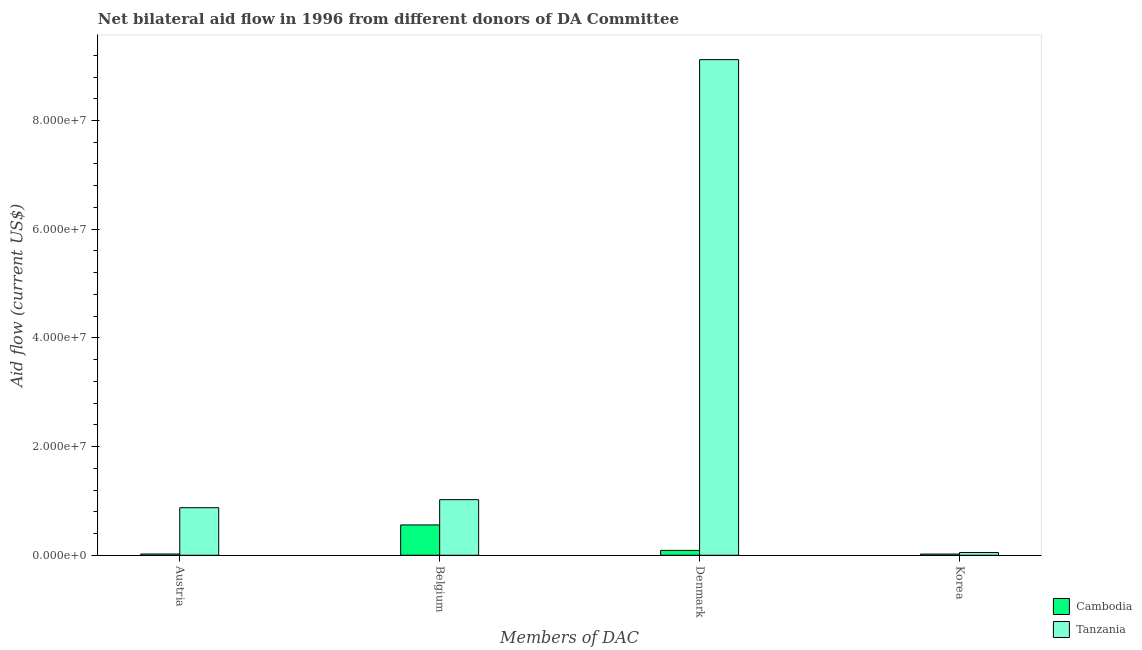How many different coloured bars are there?
Your answer should be compact. 2. How many groups of bars are there?
Offer a very short reply. 4. How many bars are there on the 1st tick from the left?
Keep it short and to the point. 2. What is the label of the 4th group of bars from the left?
Your response must be concise. Korea. What is the amount of aid given by belgium in Cambodia?
Provide a short and direct response. 5.58e+06. Across all countries, what is the maximum amount of aid given by denmark?
Give a very brief answer. 9.12e+07. Across all countries, what is the minimum amount of aid given by belgium?
Offer a terse response. 5.58e+06. In which country was the amount of aid given by austria maximum?
Keep it short and to the point. Tanzania. In which country was the amount of aid given by belgium minimum?
Provide a succinct answer. Cambodia. What is the total amount of aid given by austria in the graph?
Make the answer very short. 8.98e+06. What is the difference between the amount of aid given by korea in Cambodia and that in Tanzania?
Offer a very short reply. -2.80e+05. What is the difference between the amount of aid given by korea in Cambodia and the amount of aid given by belgium in Tanzania?
Provide a short and direct response. -1.00e+07. What is the average amount of aid given by belgium per country?
Offer a terse response. 7.90e+06. What is the difference between the amount of aid given by korea and amount of aid given by denmark in Cambodia?
Your response must be concise. -6.80e+05. What is the ratio of the amount of aid given by korea in Tanzania to that in Cambodia?
Provide a succinct answer. 2.27. Is the amount of aid given by belgium in Cambodia less than that in Tanzania?
Ensure brevity in your answer.  Yes. What is the difference between the highest and the second highest amount of aid given by denmark?
Provide a succinct answer. 9.03e+07. What is the difference between the highest and the lowest amount of aid given by austria?
Your answer should be very brief. 8.52e+06. In how many countries, is the amount of aid given by belgium greater than the average amount of aid given by belgium taken over all countries?
Make the answer very short. 1. What does the 2nd bar from the left in Belgium represents?
Offer a terse response. Tanzania. What does the 2nd bar from the right in Belgium represents?
Offer a terse response. Cambodia. Is it the case that in every country, the sum of the amount of aid given by austria and amount of aid given by belgium is greater than the amount of aid given by denmark?
Make the answer very short. No. Are all the bars in the graph horizontal?
Keep it short and to the point. No. How many countries are there in the graph?
Keep it short and to the point. 2. What is the difference between two consecutive major ticks on the Y-axis?
Provide a short and direct response. 2.00e+07. Are the values on the major ticks of Y-axis written in scientific E-notation?
Your response must be concise. Yes. Does the graph contain any zero values?
Keep it short and to the point. No. Does the graph contain grids?
Ensure brevity in your answer.  No. Where does the legend appear in the graph?
Your answer should be very brief. Bottom right. How are the legend labels stacked?
Your response must be concise. Vertical. What is the title of the graph?
Provide a succinct answer. Net bilateral aid flow in 1996 from different donors of DA Committee. Does "Suriname" appear as one of the legend labels in the graph?
Provide a succinct answer. No. What is the label or title of the X-axis?
Your response must be concise. Members of DAC. What is the label or title of the Y-axis?
Offer a very short reply. Aid flow (current US$). What is the Aid flow (current US$) of Cambodia in Austria?
Offer a terse response. 2.30e+05. What is the Aid flow (current US$) in Tanzania in Austria?
Keep it short and to the point. 8.75e+06. What is the Aid flow (current US$) in Cambodia in Belgium?
Your answer should be very brief. 5.58e+06. What is the Aid flow (current US$) in Tanzania in Belgium?
Offer a terse response. 1.02e+07. What is the Aid flow (current US$) in Tanzania in Denmark?
Your response must be concise. 9.12e+07. Across all Members of DAC, what is the maximum Aid flow (current US$) in Cambodia?
Offer a very short reply. 5.58e+06. Across all Members of DAC, what is the maximum Aid flow (current US$) in Tanzania?
Your answer should be compact. 9.12e+07. Across all Members of DAC, what is the minimum Aid flow (current US$) in Cambodia?
Keep it short and to the point. 2.20e+05. Across all Members of DAC, what is the minimum Aid flow (current US$) in Tanzania?
Give a very brief answer. 5.00e+05. What is the total Aid flow (current US$) of Cambodia in the graph?
Your answer should be compact. 6.93e+06. What is the total Aid flow (current US$) in Tanzania in the graph?
Your response must be concise. 1.11e+08. What is the difference between the Aid flow (current US$) of Cambodia in Austria and that in Belgium?
Ensure brevity in your answer.  -5.35e+06. What is the difference between the Aid flow (current US$) in Tanzania in Austria and that in Belgium?
Make the answer very short. -1.48e+06. What is the difference between the Aid flow (current US$) in Cambodia in Austria and that in Denmark?
Provide a succinct answer. -6.70e+05. What is the difference between the Aid flow (current US$) in Tanzania in Austria and that in Denmark?
Provide a short and direct response. -8.24e+07. What is the difference between the Aid flow (current US$) in Tanzania in Austria and that in Korea?
Your answer should be compact. 8.25e+06. What is the difference between the Aid flow (current US$) of Cambodia in Belgium and that in Denmark?
Offer a very short reply. 4.68e+06. What is the difference between the Aid flow (current US$) of Tanzania in Belgium and that in Denmark?
Your answer should be compact. -8.10e+07. What is the difference between the Aid flow (current US$) in Cambodia in Belgium and that in Korea?
Ensure brevity in your answer.  5.36e+06. What is the difference between the Aid flow (current US$) of Tanzania in Belgium and that in Korea?
Your answer should be very brief. 9.73e+06. What is the difference between the Aid flow (current US$) of Cambodia in Denmark and that in Korea?
Ensure brevity in your answer.  6.80e+05. What is the difference between the Aid flow (current US$) of Tanzania in Denmark and that in Korea?
Provide a short and direct response. 9.07e+07. What is the difference between the Aid flow (current US$) of Cambodia in Austria and the Aid flow (current US$) of Tanzania in Belgium?
Offer a very short reply. -1.00e+07. What is the difference between the Aid flow (current US$) of Cambodia in Austria and the Aid flow (current US$) of Tanzania in Denmark?
Offer a very short reply. -9.10e+07. What is the difference between the Aid flow (current US$) in Cambodia in Belgium and the Aid flow (current US$) in Tanzania in Denmark?
Your response must be concise. -8.56e+07. What is the difference between the Aid flow (current US$) in Cambodia in Belgium and the Aid flow (current US$) in Tanzania in Korea?
Give a very brief answer. 5.08e+06. What is the average Aid flow (current US$) in Cambodia per Members of DAC?
Provide a short and direct response. 1.73e+06. What is the average Aid flow (current US$) of Tanzania per Members of DAC?
Offer a terse response. 2.77e+07. What is the difference between the Aid flow (current US$) of Cambodia and Aid flow (current US$) of Tanzania in Austria?
Give a very brief answer. -8.52e+06. What is the difference between the Aid flow (current US$) of Cambodia and Aid flow (current US$) of Tanzania in Belgium?
Provide a succinct answer. -4.65e+06. What is the difference between the Aid flow (current US$) in Cambodia and Aid flow (current US$) in Tanzania in Denmark?
Make the answer very short. -9.03e+07. What is the difference between the Aid flow (current US$) of Cambodia and Aid flow (current US$) of Tanzania in Korea?
Give a very brief answer. -2.80e+05. What is the ratio of the Aid flow (current US$) of Cambodia in Austria to that in Belgium?
Your response must be concise. 0.04. What is the ratio of the Aid flow (current US$) in Tanzania in Austria to that in Belgium?
Your answer should be very brief. 0.86. What is the ratio of the Aid flow (current US$) of Cambodia in Austria to that in Denmark?
Your response must be concise. 0.26. What is the ratio of the Aid flow (current US$) of Tanzania in Austria to that in Denmark?
Your answer should be compact. 0.1. What is the ratio of the Aid flow (current US$) in Cambodia in Austria to that in Korea?
Your answer should be compact. 1.05. What is the ratio of the Aid flow (current US$) of Cambodia in Belgium to that in Denmark?
Offer a terse response. 6.2. What is the ratio of the Aid flow (current US$) of Tanzania in Belgium to that in Denmark?
Your answer should be compact. 0.11. What is the ratio of the Aid flow (current US$) in Cambodia in Belgium to that in Korea?
Offer a terse response. 25.36. What is the ratio of the Aid flow (current US$) in Tanzania in Belgium to that in Korea?
Make the answer very short. 20.46. What is the ratio of the Aid flow (current US$) in Cambodia in Denmark to that in Korea?
Offer a very short reply. 4.09. What is the ratio of the Aid flow (current US$) in Tanzania in Denmark to that in Korea?
Provide a short and direct response. 182.4. What is the difference between the highest and the second highest Aid flow (current US$) of Cambodia?
Make the answer very short. 4.68e+06. What is the difference between the highest and the second highest Aid flow (current US$) in Tanzania?
Ensure brevity in your answer.  8.10e+07. What is the difference between the highest and the lowest Aid flow (current US$) in Cambodia?
Provide a short and direct response. 5.36e+06. What is the difference between the highest and the lowest Aid flow (current US$) in Tanzania?
Your answer should be compact. 9.07e+07. 